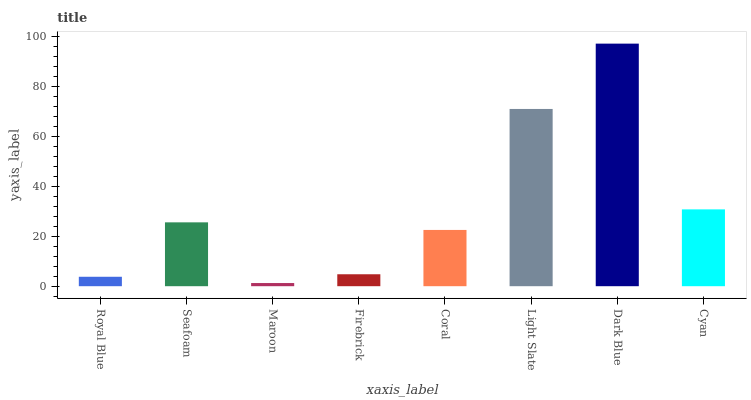Is Maroon the minimum?
Answer yes or no. Yes. Is Dark Blue the maximum?
Answer yes or no. Yes. Is Seafoam the minimum?
Answer yes or no. No. Is Seafoam the maximum?
Answer yes or no. No. Is Seafoam greater than Royal Blue?
Answer yes or no. Yes. Is Royal Blue less than Seafoam?
Answer yes or no. Yes. Is Royal Blue greater than Seafoam?
Answer yes or no. No. Is Seafoam less than Royal Blue?
Answer yes or no. No. Is Seafoam the high median?
Answer yes or no. Yes. Is Coral the low median?
Answer yes or no. Yes. Is Royal Blue the high median?
Answer yes or no. No. Is Light Slate the low median?
Answer yes or no. No. 